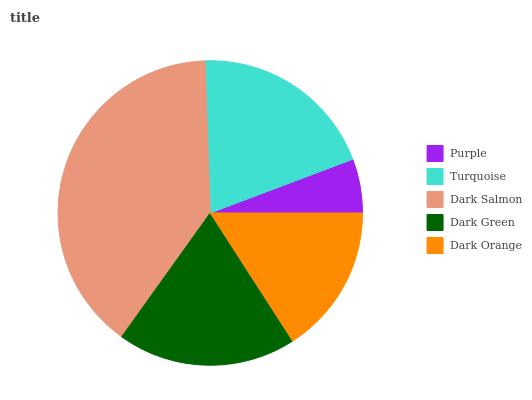Is Purple the minimum?
Answer yes or no. Yes. Is Dark Salmon the maximum?
Answer yes or no. Yes. Is Turquoise the minimum?
Answer yes or no. No. Is Turquoise the maximum?
Answer yes or no. No. Is Turquoise greater than Purple?
Answer yes or no. Yes. Is Purple less than Turquoise?
Answer yes or no. Yes. Is Purple greater than Turquoise?
Answer yes or no. No. Is Turquoise less than Purple?
Answer yes or no. No. Is Dark Green the high median?
Answer yes or no. Yes. Is Dark Green the low median?
Answer yes or no. Yes. Is Purple the high median?
Answer yes or no. No. Is Turquoise the low median?
Answer yes or no. No. 